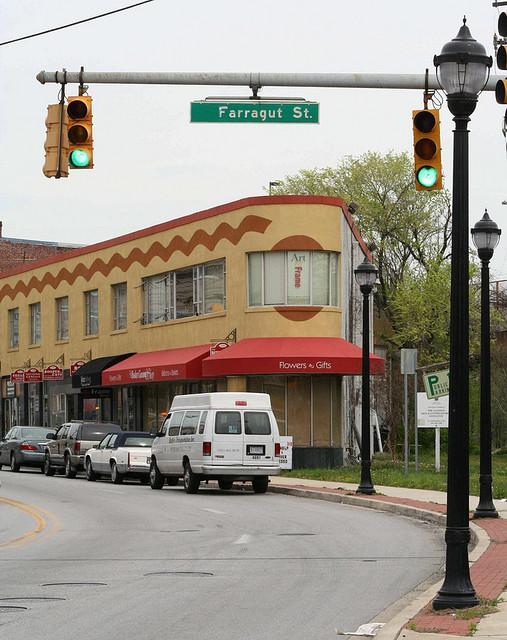Are the street lights over 10 feet tall?
Be succinct. Yes. Is the green light on?
Concise answer only. Yes. Is this a two way street?
Concise answer only. Yes. 